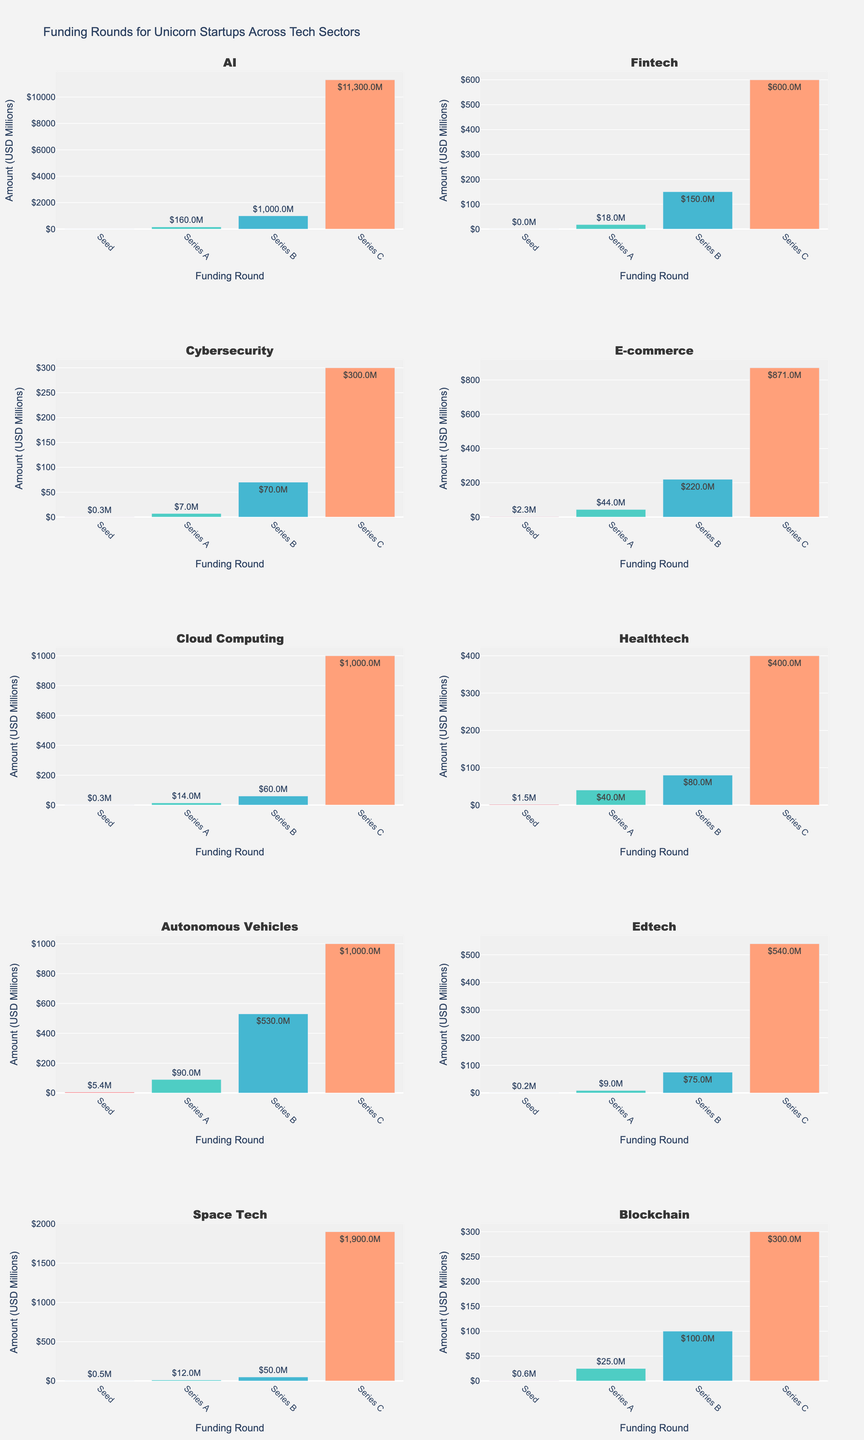what is the frequency of hate crimes against Muslims in California in 2021? Locate California on the x-axis in the subplot for the year 2021 and read the corresponding bar height or value.
Answer: 186 Which state had the highest increase in hate crimes from 2013 to 2021? First, calculate the difference between 2021 and 2013 for each state. Then, identify the state with the highest difference. California: (186 - 137) = 49, New York: (131 - 82) = 49, Texas: (89 - 48) = 41, Florida: (61 - 36) = 25, Illinois: (53 - 31) = 22, New Jersey: (47 - 26) = 21, Michigan: (41 - 22) = 19, Virginia: (35 - 18) = 17, Ohio: (30 - 16) = 14, Pennsylvania: (28 - 14) = 14. Both California and New York have the highest increase of 49.
Answer: California and New York Which year had the highest total frequency of hate crimes across all states? Sum the frequency values of all states for each year and compare the totals. 2013: 430, 2015: 554, 2017: 611, 2019: 657, 2021: 701. 2021 has the highest total.
Answer: 2021 Did hate crimes increase or decrease in Texas from 2013 to 2017? Locate Texas in the subplots for 2013 (48) and 2017 (75). Compare the values to see that it increased.
Answer: Increase What is the average frequency of hate crimes in Virginia over the years? Sum the frequency values for Virginia: 18 (2013), 23 (2015), 28 (2017), 32 (2019), 35 (2021) and divide by the number of years (5). (18+23+28+32+35) / 5 = 27.2
Answer: 27.2 How many states had a frequency of hate crimes greater than 50 in 2015? Identify each bar in the 2015 subplot and count how many states have a frequency greater than 50. California (184), New York (105), Texas (63), Florida (42), Illinois (38), New Jersey (33), Michigan (28), Virginia (23), Ohio (20), Pennsylvania (18). Only California, New York, and Texas have values over 50.
Answer: 3 What is the total frequency of hate crimes in New Jersey over the past decade? Sum the frequencies for New Jersey from all years: 26 (2013), 33 (2015), 39 (2017), 44 (2019), 47 (2021). 26 + 33 + 39 + 44 + 47 = 189
Answer: 189 Which state had the lowest frequency in 2019? Identify the state with the smallest bar in the 2019 subplot. Ohio: 27, Pennsylvania: 25  Pennsylvania has the lowest.
Answer: Pennsylvania 